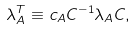<formula> <loc_0><loc_0><loc_500><loc_500>\lambda _ { A } ^ { T } \equiv c _ { A } C ^ { - 1 } \lambda _ { A } C ,</formula> 